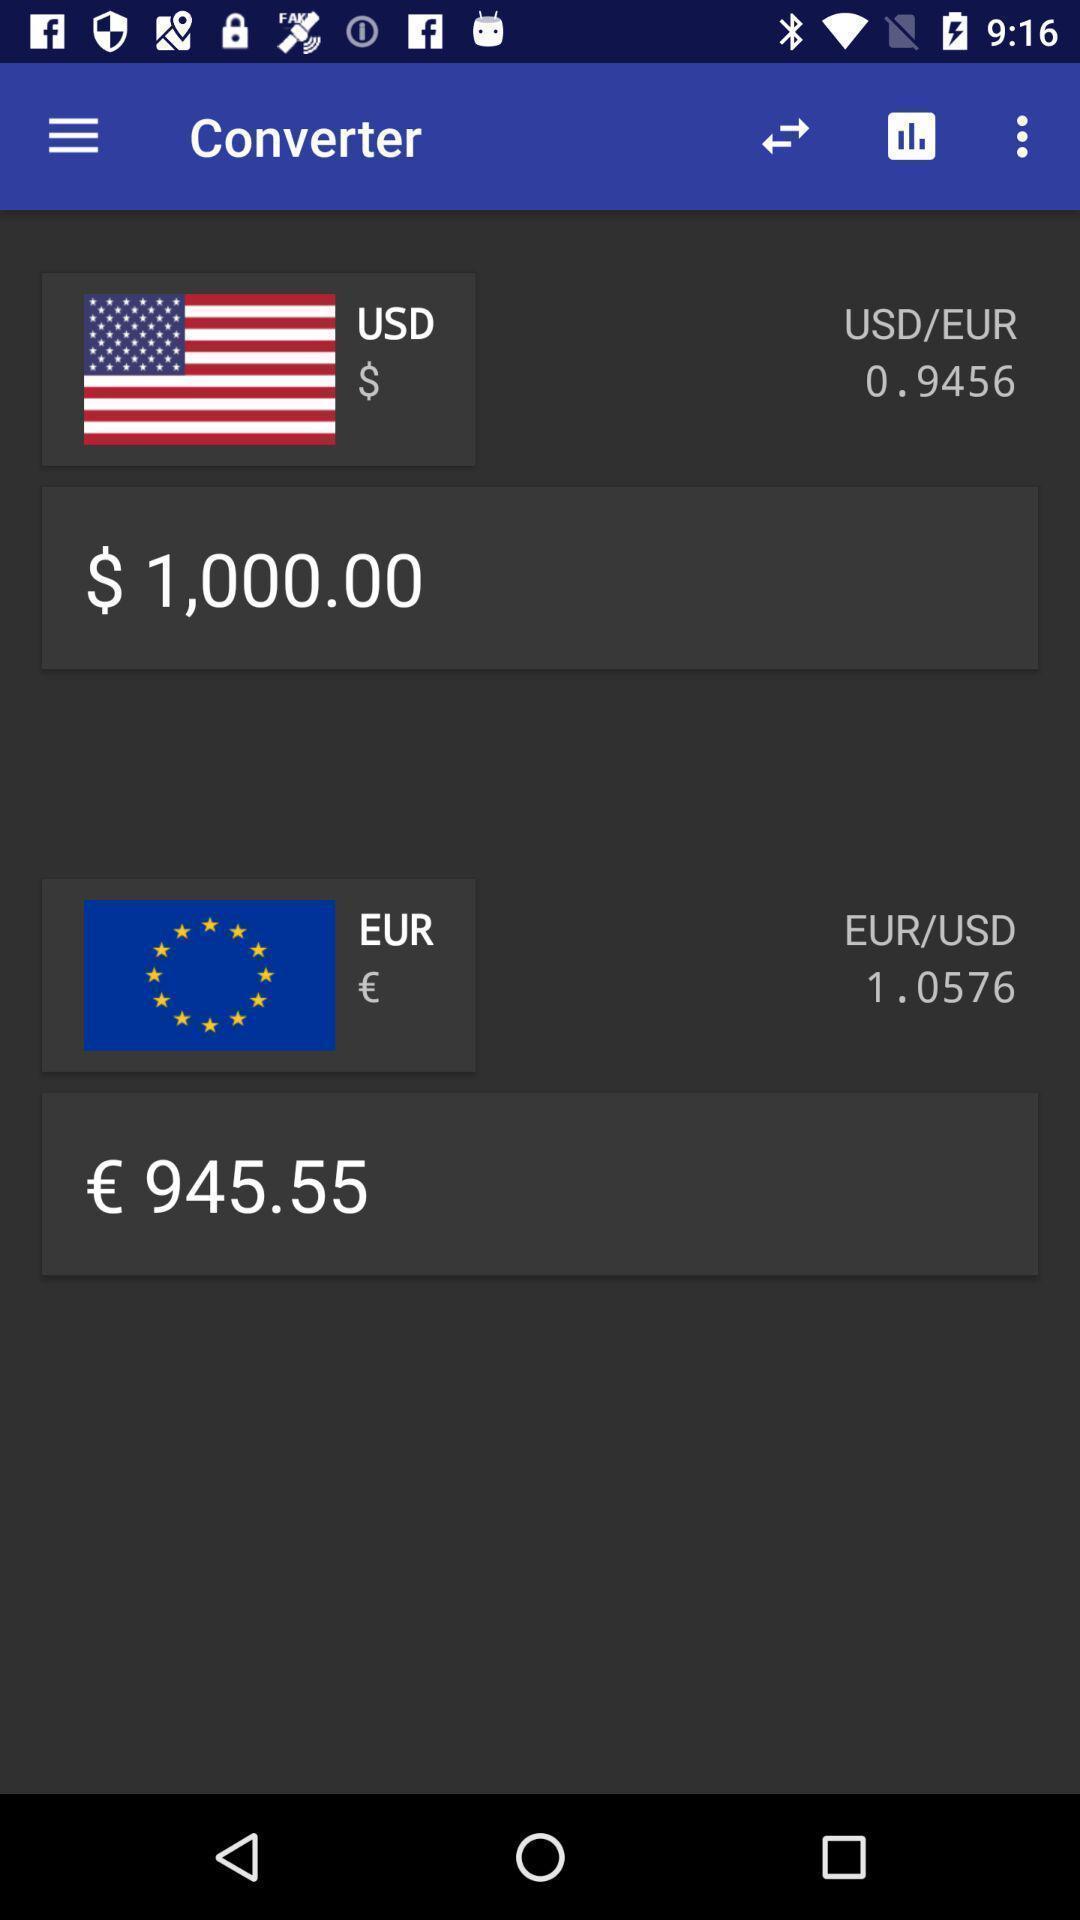Give me a narrative description of this picture. Screen showing amount converter page. 